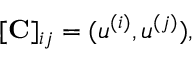<formula> <loc_0><loc_0><loc_500><loc_500>[ C ] _ { i j } = ( u ^ { ( i ) } , u ^ { ( j ) } ) ,</formula> 